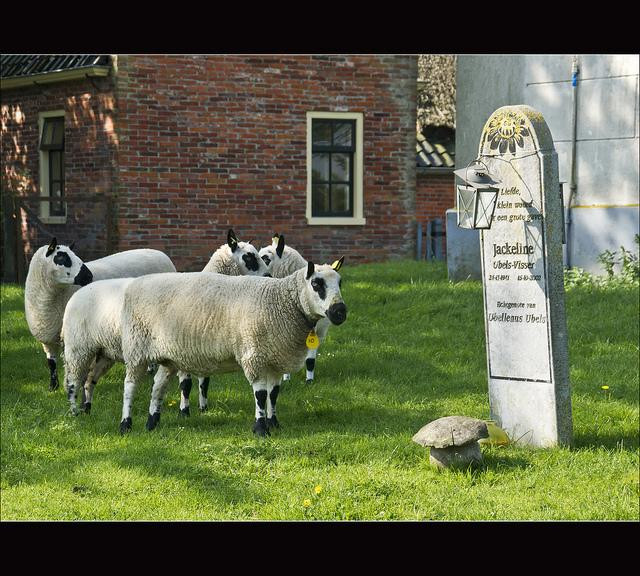What is around the animal in the foreground's neck? tag 